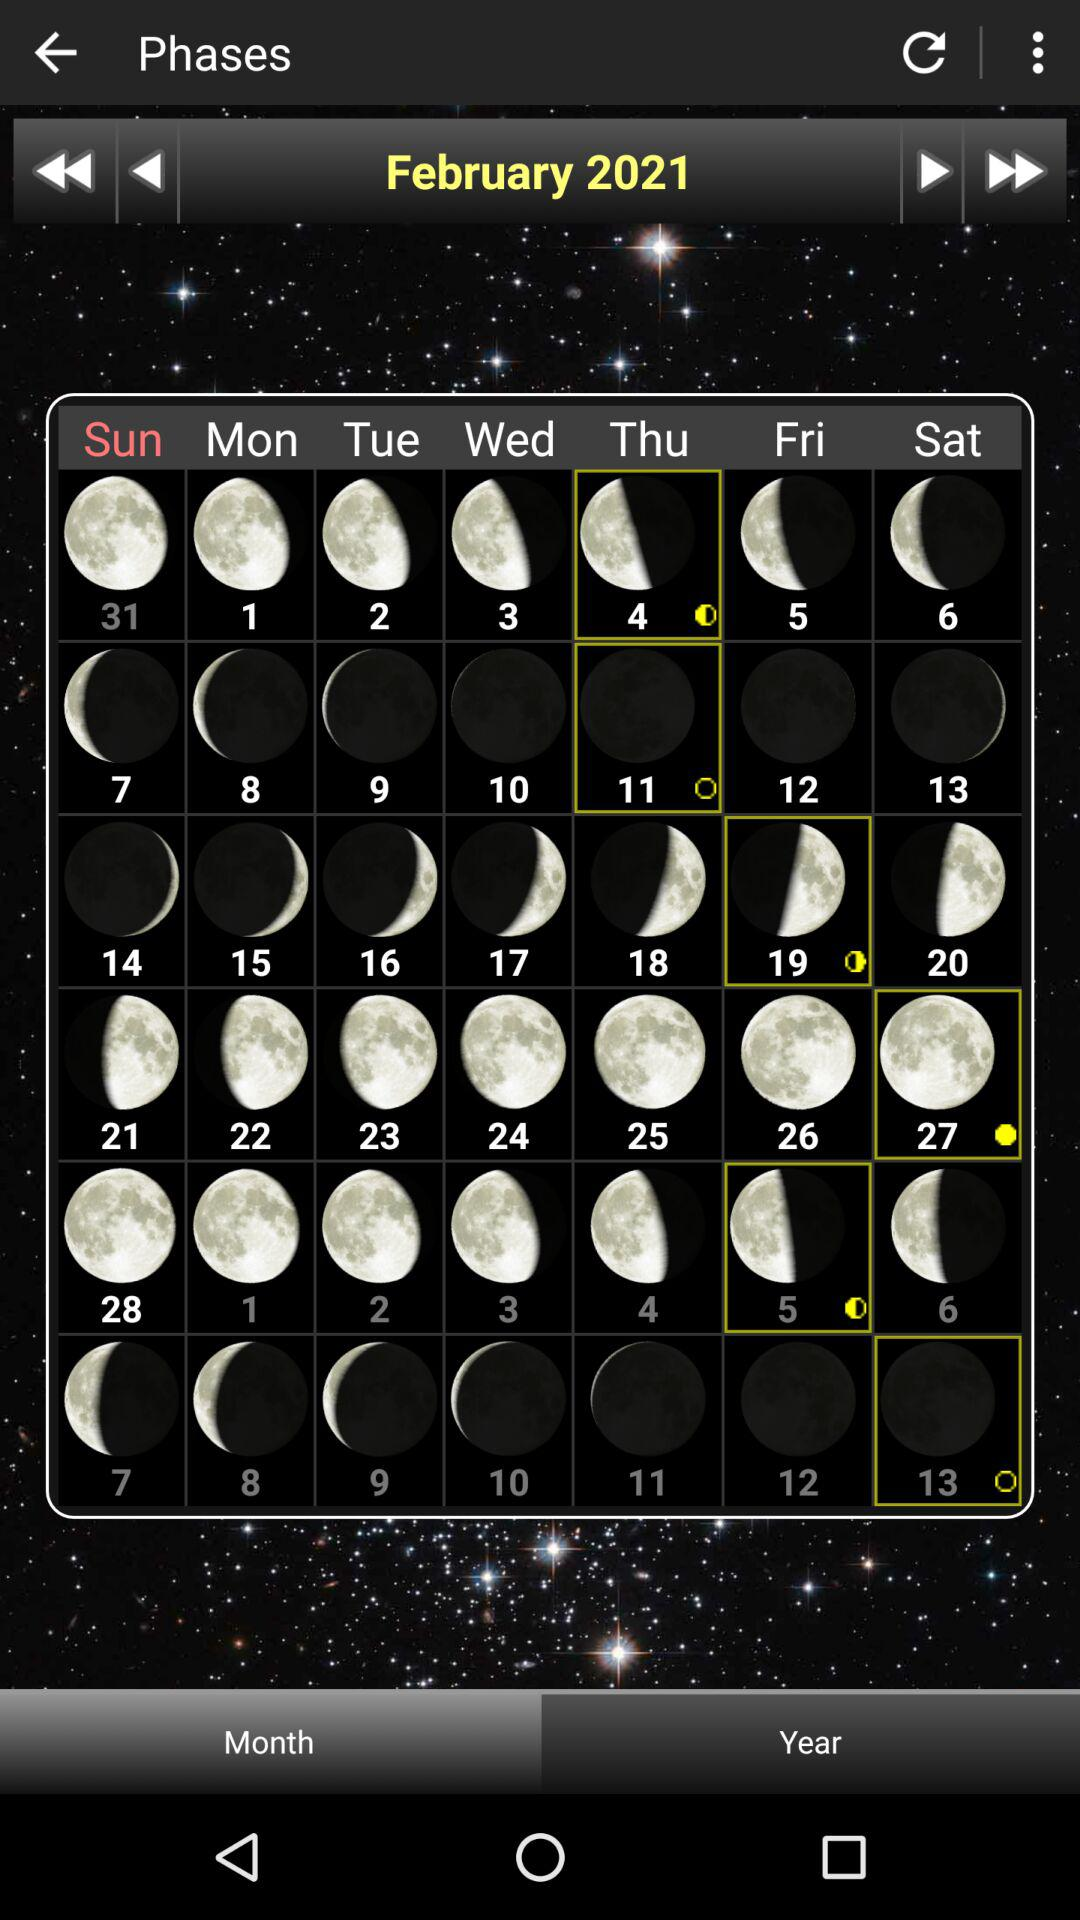What is the current month and year? The current month is February and the year is 2021. 